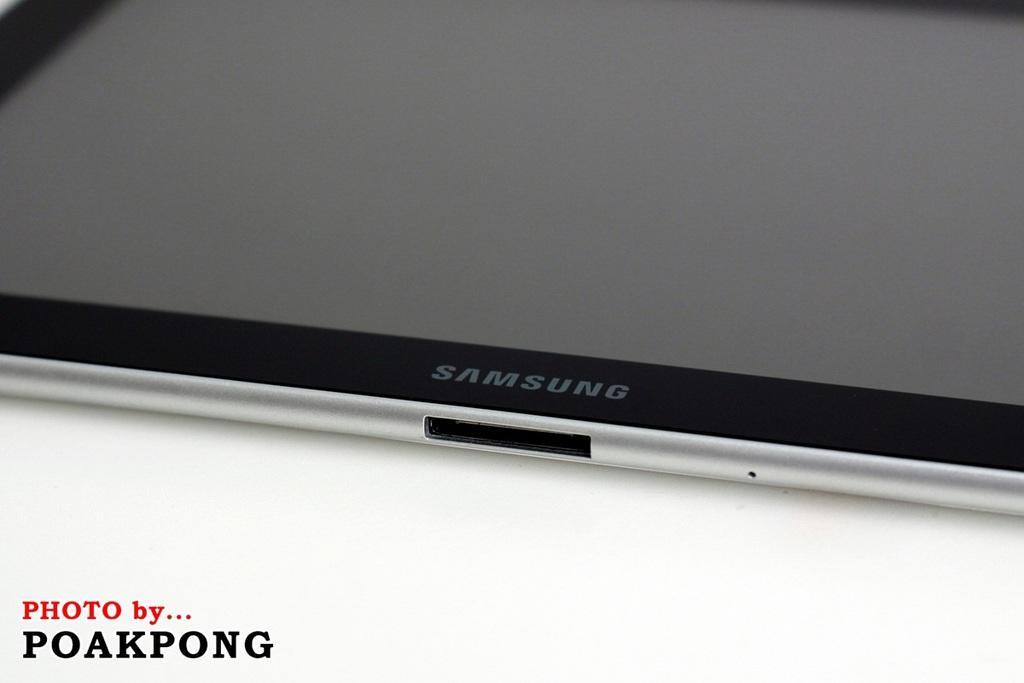Provide a one-sentence caption for the provided image. A samsung device with the photo by poakpong. 